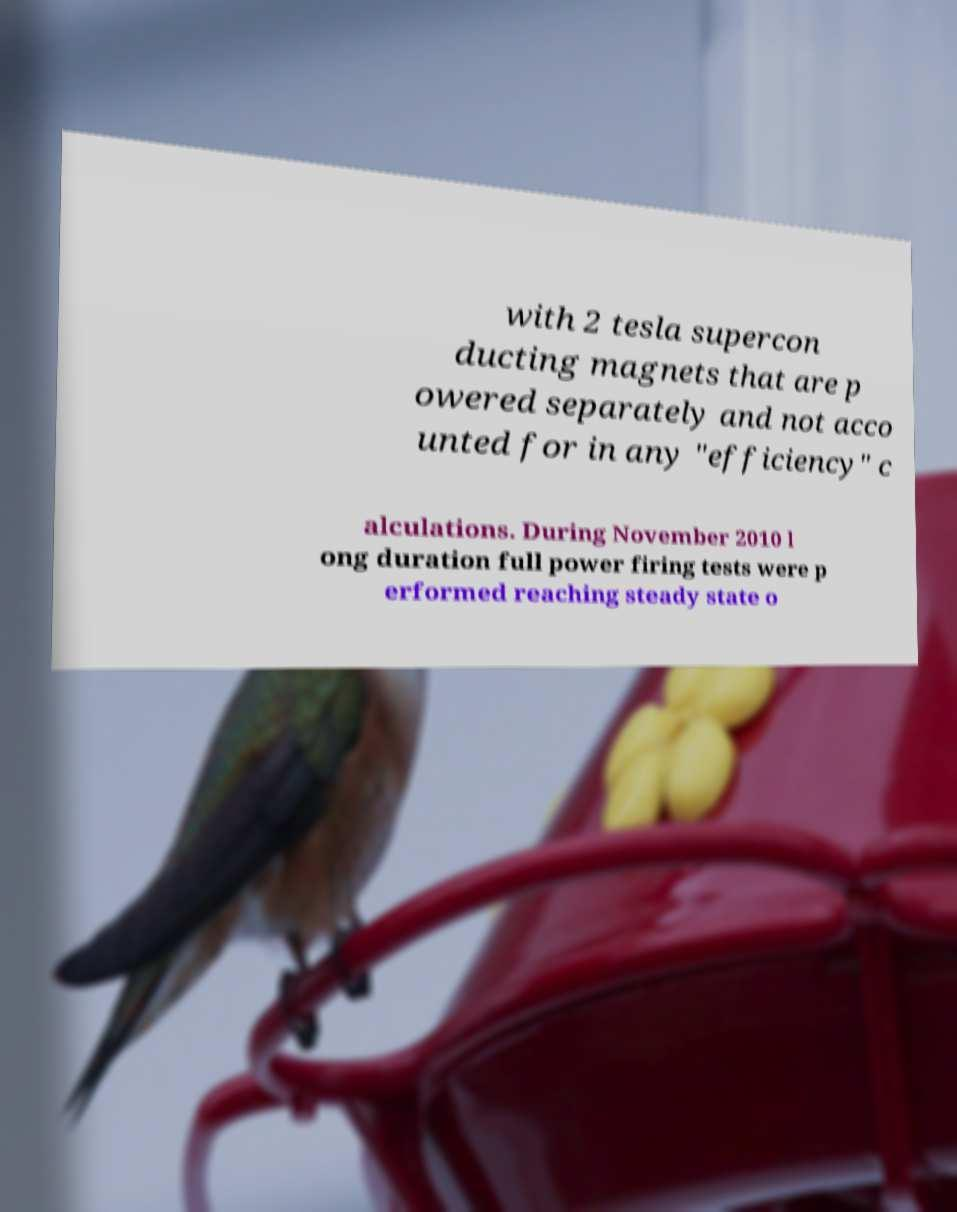There's text embedded in this image that I need extracted. Can you transcribe it verbatim? with 2 tesla supercon ducting magnets that are p owered separately and not acco unted for in any "efficiency" c alculations. During November 2010 l ong duration full power firing tests were p erformed reaching steady state o 